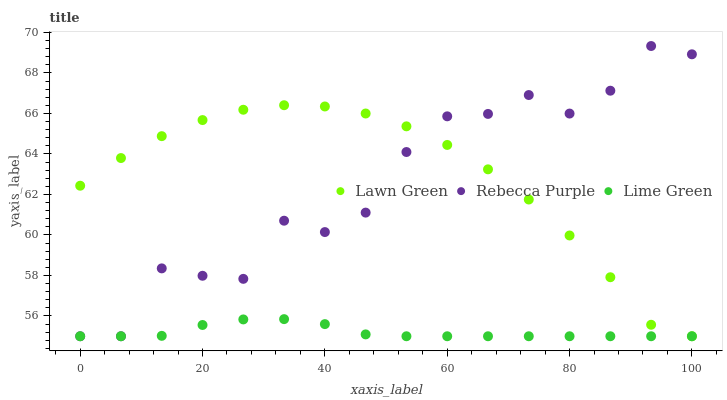Does Lime Green have the minimum area under the curve?
Answer yes or no. Yes. Does Lawn Green have the maximum area under the curve?
Answer yes or no. Yes. Does Rebecca Purple have the minimum area under the curve?
Answer yes or no. No. Does Rebecca Purple have the maximum area under the curve?
Answer yes or no. No. Is Lime Green the smoothest?
Answer yes or no. Yes. Is Rebecca Purple the roughest?
Answer yes or no. Yes. Is Rebecca Purple the smoothest?
Answer yes or no. No. Is Lime Green the roughest?
Answer yes or no. No. Does Lawn Green have the lowest value?
Answer yes or no. Yes. Does Rebecca Purple have the highest value?
Answer yes or no. Yes. Does Lime Green have the highest value?
Answer yes or no. No. Does Lawn Green intersect Rebecca Purple?
Answer yes or no. Yes. Is Lawn Green less than Rebecca Purple?
Answer yes or no. No. Is Lawn Green greater than Rebecca Purple?
Answer yes or no. No. 